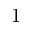Convert formula to latex. <formula><loc_0><loc_0><loc_500><loc_500>1</formula> 